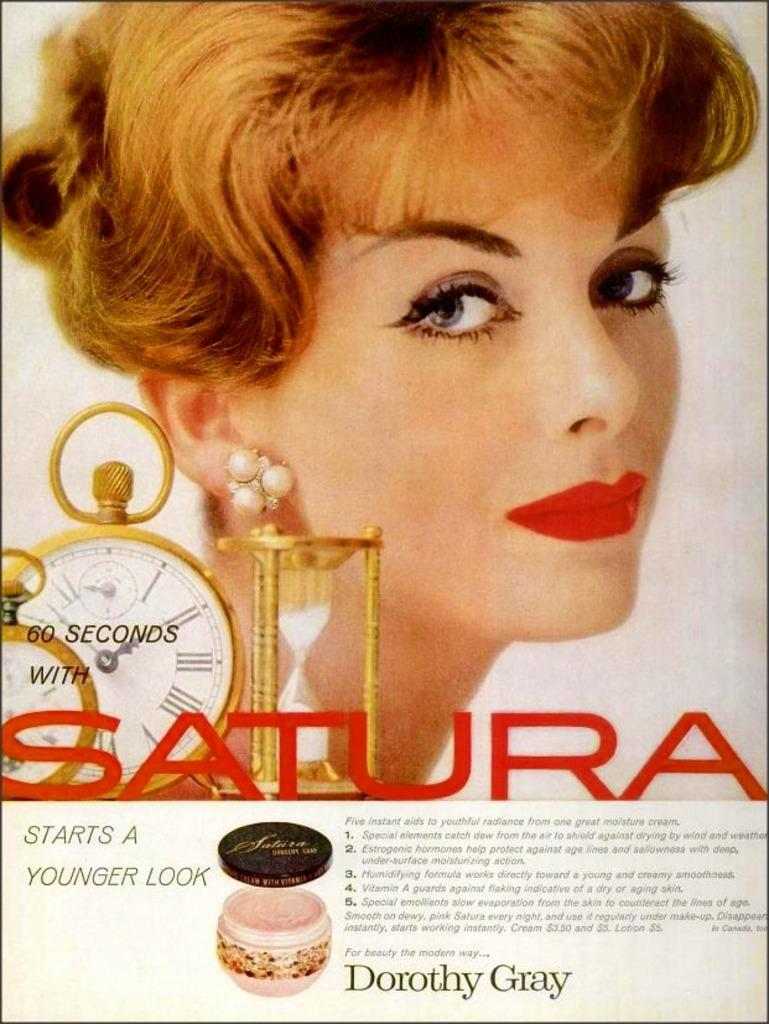<image>
Present a compact description of the photo's key features. An advertisement for Satura, a beauty product, shows the close up of a woman's face. 